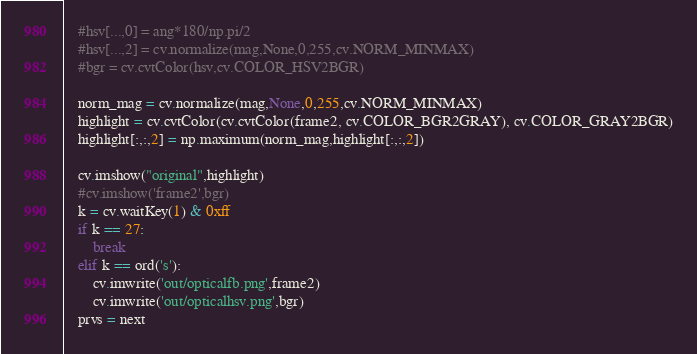Convert code to text. <code><loc_0><loc_0><loc_500><loc_500><_Python_>
    #hsv[...,0] = ang*180/np.pi/2
    #hsv[...,2] = cv.normalize(mag,None,0,255,cv.NORM_MINMAX)
    #bgr = cv.cvtColor(hsv,cv.COLOR_HSV2BGR)
    
    norm_mag = cv.normalize(mag,None,0,255,cv.NORM_MINMAX)
    highlight = cv.cvtColor(cv.cvtColor(frame2, cv.COLOR_BGR2GRAY), cv.COLOR_GRAY2BGR)
    highlight[:,:,2] = np.maximum(norm_mag,highlight[:,:,2])

    cv.imshow("original",highlight)
    #cv.imshow('frame2',bgr)
    k = cv.waitKey(1) & 0xff
    if k == 27:
        break
    elif k == ord('s'):
        cv.imwrite('out/opticalfb.png',frame2)
        cv.imwrite('out/opticalhsv.png',bgr)
    prvs = next</code> 